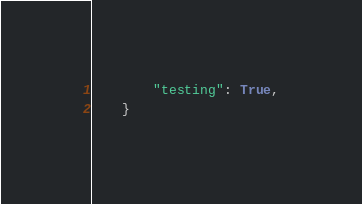Convert code to text. <code><loc_0><loc_0><loc_500><loc_500><_Python_>        "testing": True,
    }
</code> 